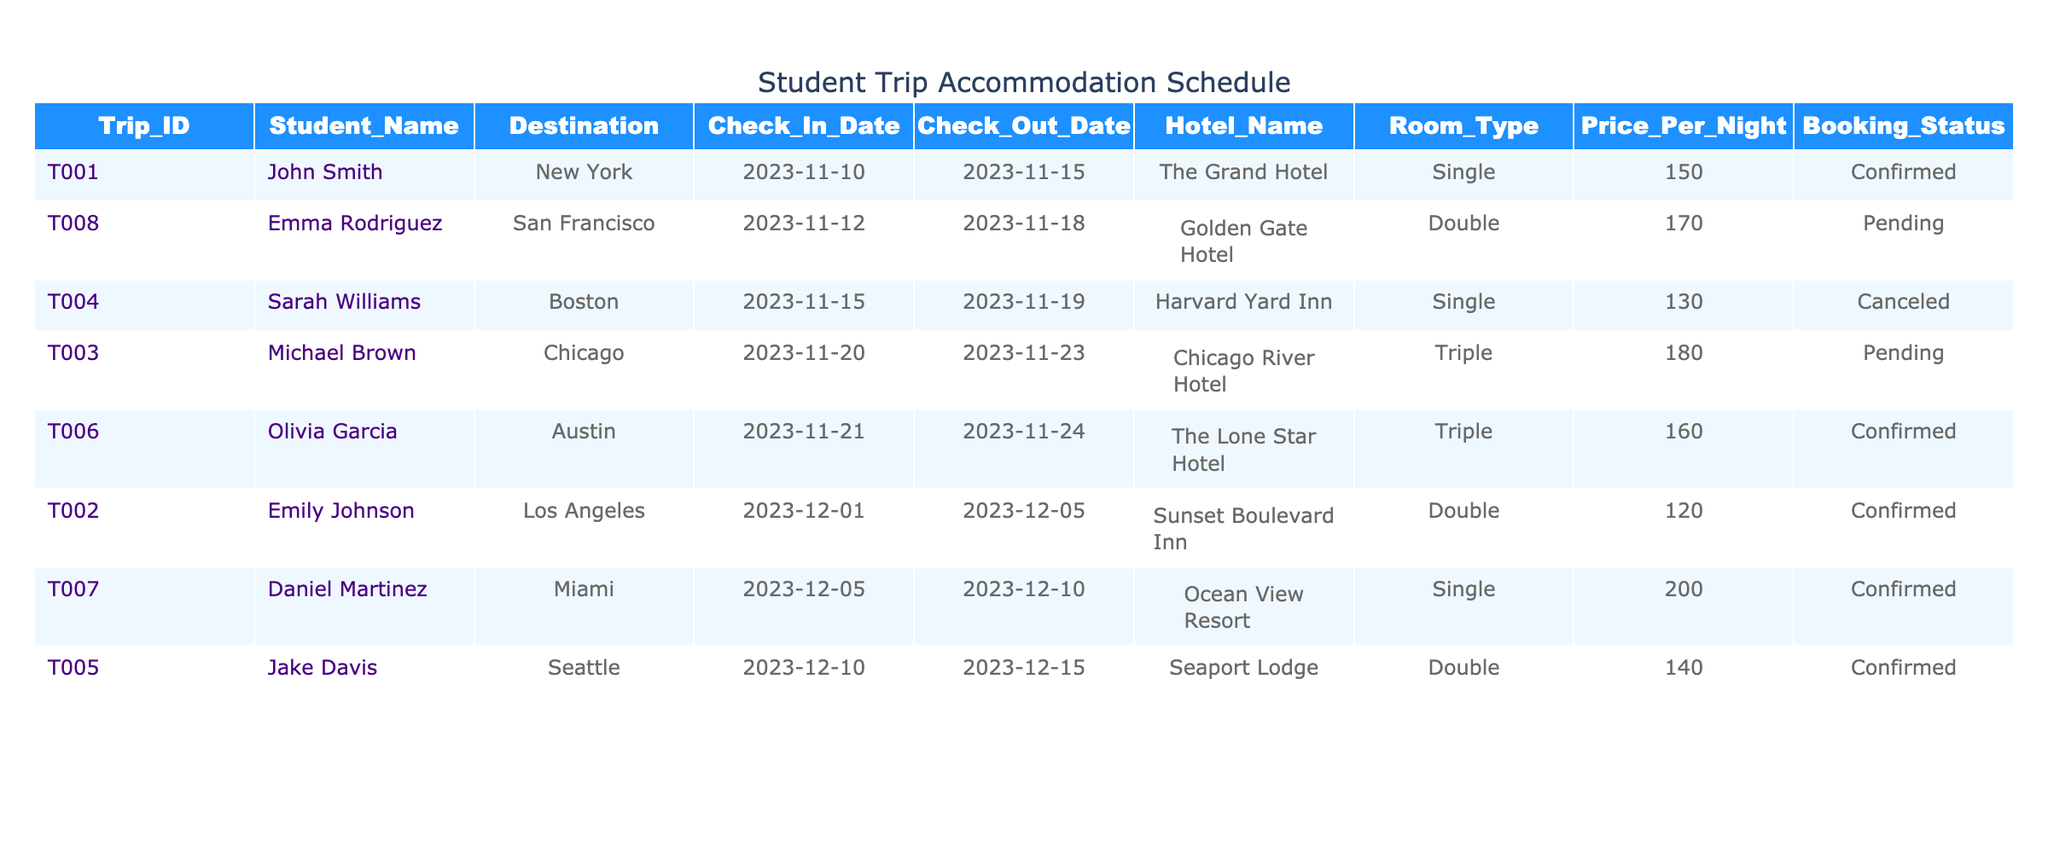What is the total price for the hotel reservation for John Smith? John Smith's reservation for The Grand Hotel is for 5 nights (from November 10 to November 15). The price per night is $150. Thus, the total price is calculated by multiplying 150 by 5, which equals 750.
Answer: 750 Is the booking status for Jake Davis's accommodation confirmed? The table shows that the booking status for Jake Davis's accommodation at Seaport Lodge is listed as "Confirmed." Therefore, the statement is true.
Answer: Yes How many students have their accommodations in the "Pending" status? From the table, there are two entries with a booking status of "Pending": Michael Brown and Emma Rodriguez. Therefore, there are 2 students with accommodations in pending status.
Answer: 2 What is the average price per night for all confirmed accommodations? The confirmed accommodations' prices per night are $150, $120, $140, $160, and $200. To find the average, we add these prices: 150 + 120 + 140 + 160 + 200 = 770. Then divide this sum by the number of confirmed bookings (5) to find the average: 770 / 5 = 154.
Answer: 154 In which hotel is Sarah Williams's accommodation and what is its booking status? Sarah Williams's accommodation is at Harvard Yard Inn, and the booking status is "Canceled," as per the table.
Answer: Harvard Yard Inn, Canceled What is the difference in nightly price between the most expensive and the least expensive confirmed accommodation? The most expensive confirmed accommodation is Daniel Martinez's at Ocean View Resort for $200 per night, and the least expensive confirmed accommodation is Emily Johnson's at Sunset Boulevard Inn for $120 per night. The difference is calculated as 200 - 120 = 80.
Answer: 80 Which student has a reservation from December 1st to December 5th? The table indicates that Emily Johnson has a reservation in Los Angeles from December 1 to December 5, hence she is the student in question.
Answer: Emily Johnson Is there an accommodation with a booking status of "Canceled"? Yes, the table shows that Sarah Williams's booking is marked as "Canceled."
Answer: Yes 